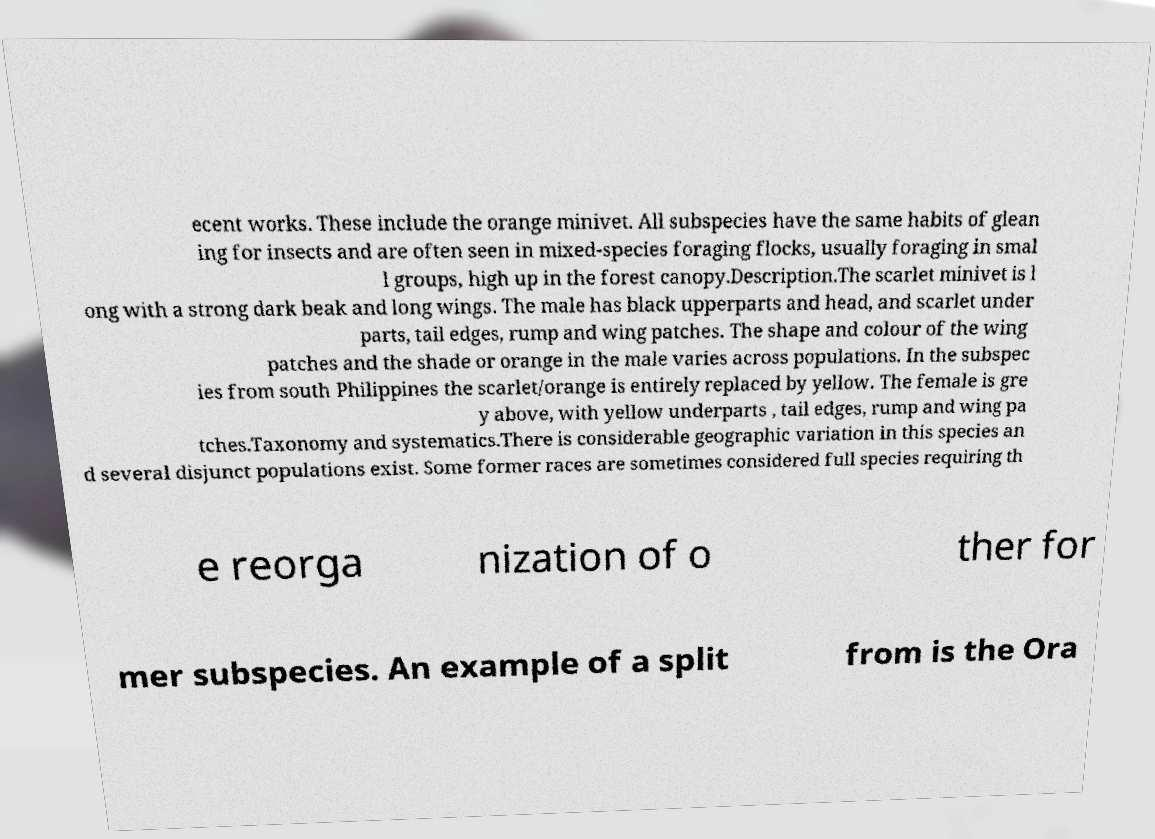Can you accurately transcribe the text from the provided image for me? ecent works. These include the orange minivet. All subspecies have the same habits of glean ing for insects and are often seen in mixed-species foraging flocks, usually foraging in smal l groups, high up in the forest canopy.Description.The scarlet minivet is l ong with a strong dark beak and long wings. The male has black upperparts and head, and scarlet under parts, tail edges, rump and wing patches. The shape and colour of the wing patches and the shade or orange in the male varies across populations. In the subspec ies from south Philippines the scarlet/orange is entirely replaced by yellow. The female is gre y above, with yellow underparts , tail edges, rump and wing pa tches.Taxonomy and systematics.There is considerable geographic variation in this species an d several disjunct populations exist. Some former races are sometimes considered full species requiring th e reorga nization of o ther for mer subspecies. An example of a split from is the Ora 